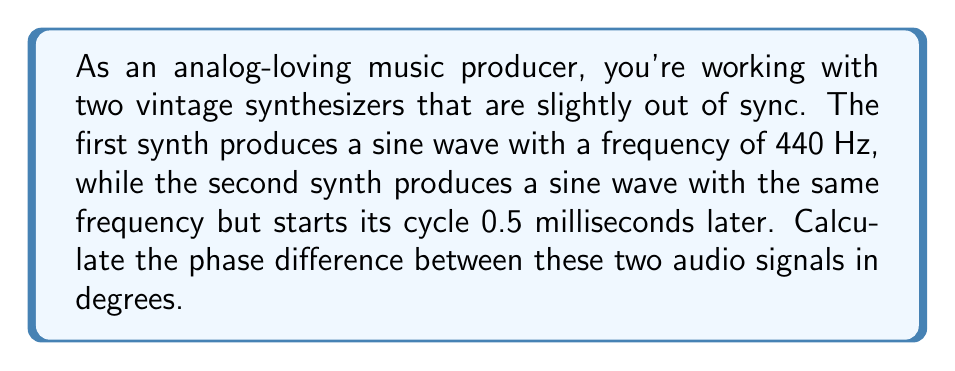Could you help me with this problem? To solve this problem, we need to follow these steps:

1) First, let's recall that phase is a measure of the position in the cycle of a waveform, usually expressed in degrees or radians. A complete cycle is 360° or 2π radians.

2) We know that the frequency of both signals is 440 Hz. This means that one complete cycle takes:

   $$T = \frac{1}{f} = \frac{1}{440} \approx 0.002273 \text{ seconds}$$

3) The second signal starts 0.5 milliseconds (ms) later, which is:

   $$0.5 \text{ ms} = 0.0005 \text{ seconds}$$

4) To find the phase difference, we need to determine what fraction of a complete cycle this time delay represents. We can do this by dividing the time delay by the period:

   $$\text{Fraction of cycle} = \frac{\text{Time delay}}{\text{Period}} = \frac{0.0005}{0.002273} \approx 0.2200$$

5) To convert this to degrees, we multiply by 360°:

   $$\text{Phase difference} = 0.2200 \times 360° = 79.2°$$

Therefore, the phase difference between the two audio signals is approximately 79.2°.
Answer: 79.2° 